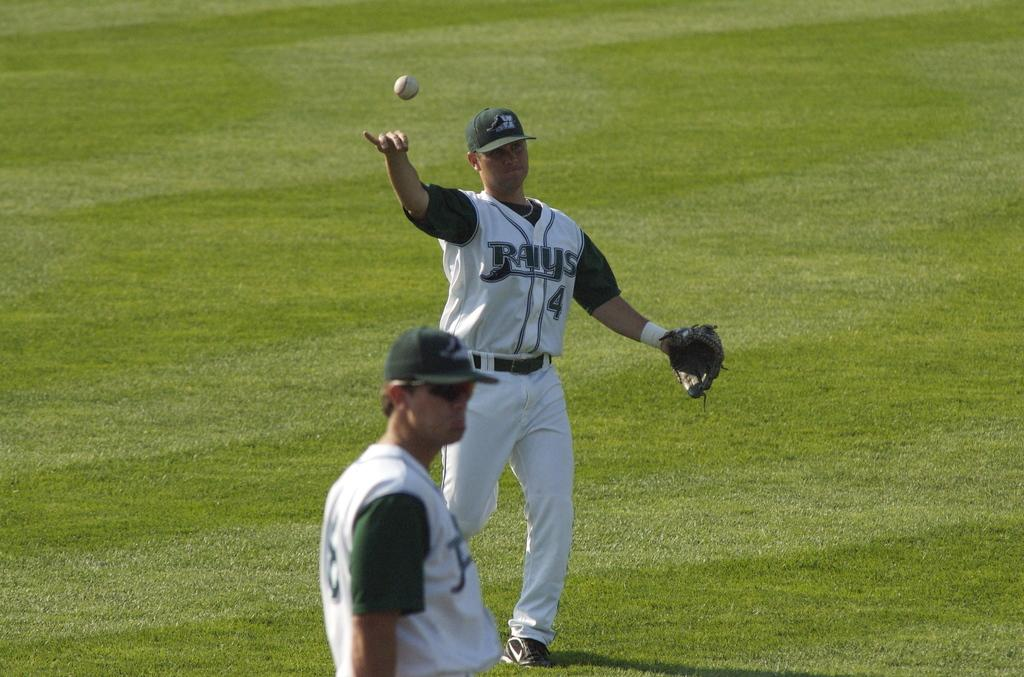What is the main subject of the image? There is a man in the image. What might the man be doing in the image? The man might be walking. Can you describe the position of the man in the image? There is a man standing in the foreground of the image. What is happening with the ball in the image? There is a ball in the air at the top of the image. What type of surface is visible at the bottom of the image? There is grass visible at the bottom of the image. How many quince trees are visible in the image? There are no quince trees present in the image. What type of mine is depicted in the image? There is no mine present in the image. 